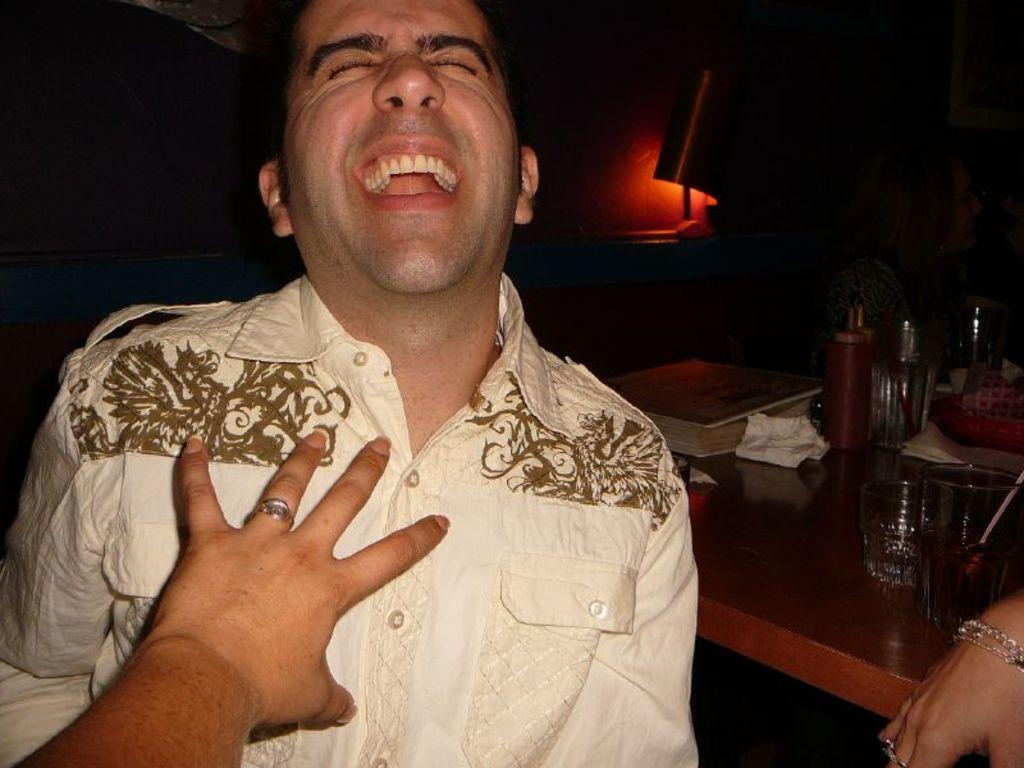Who is present in the image? There is a man in the image. What is the man wearing? The man is wearing a white shirt. What can be seen on the table in the image? There are glasses and a tray on the table. What time does the clock on the table show in the image? There is no clock present in the image, so it is not possible to determine the time. 